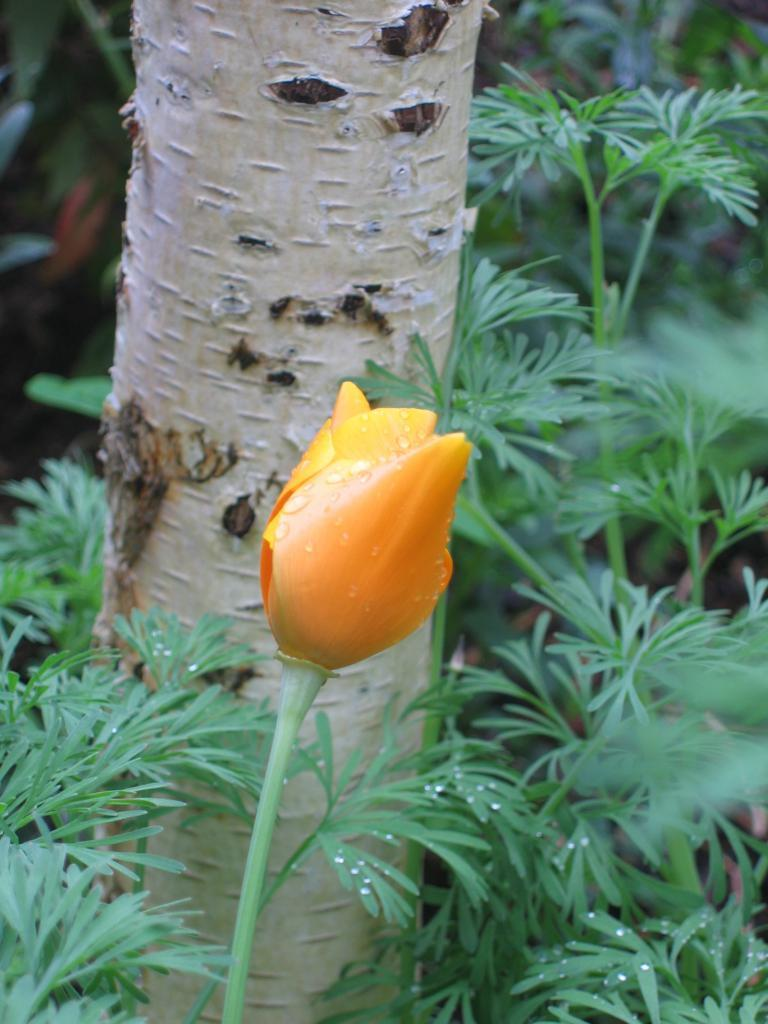What type of flower is in the image? There is a tulip in the image. Where is the tulip located in the image? The tulip is in the front of the image. What other plant can be seen in the image? There is a tree in the image. What is growing around the tree in the image? The tree has plants around it. Can you see a deer taking a bath near the tulip in the image? No, there is no deer or bath present in the image. 